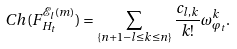<formula> <loc_0><loc_0><loc_500><loc_500>C h ( F ^ { \mathcal { E } _ { l } ( m ) } _ { H _ { t } } ) = \sum _ { \{ n + 1 - l \leq k \leq n \} } \frac { c _ { l , k } } { k ! } \omega _ { \varphi _ { t } } ^ { k } .</formula> 